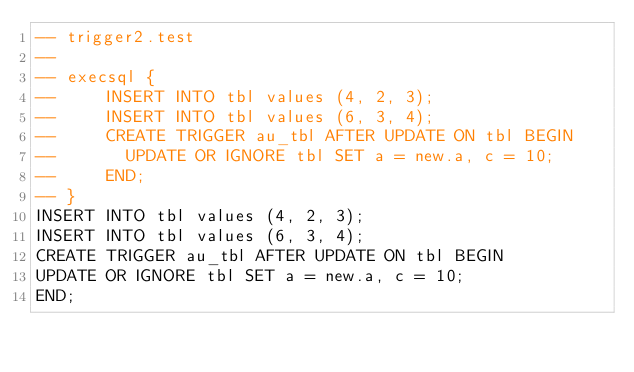<code> <loc_0><loc_0><loc_500><loc_500><_SQL_>-- trigger2.test
-- 
-- execsql {
--     INSERT INTO tbl values (4, 2, 3);
--     INSERT INTO tbl values (6, 3, 4);
--     CREATE TRIGGER au_tbl AFTER UPDATE ON tbl BEGIN
--       UPDATE OR IGNORE tbl SET a = new.a, c = 10;
--     END;
-- }
INSERT INTO tbl values (4, 2, 3);
INSERT INTO tbl values (6, 3, 4);
CREATE TRIGGER au_tbl AFTER UPDATE ON tbl BEGIN
UPDATE OR IGNORE tbl SET a = new.a, c = 10;
END;</code> 